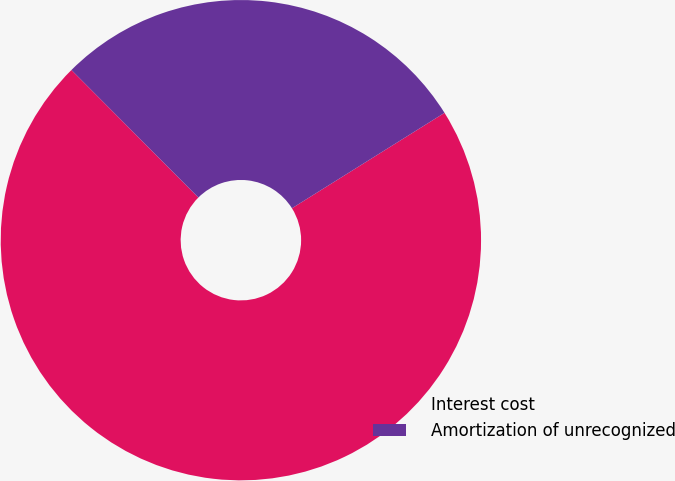<chart> <loc_0><loc_0><loc_500><loc_500><pie_chart><fcel>Interest cost<fcel>Amortization of unrecognized<nl><fcel>71.43%<fcel>28.57%<nl></chart> 